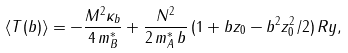Convert formula to latex. <formula><loc_0><loc_0><loc_500><loc_500>\langle T ( b ) \rangle = - \frac { M ^ { 2 } \kappa _ { b } } { 4 \, m _ { B } ^ { * } } + \frac { N ^ { 2 } } { 2 \, m _ { A } ^ { * } \, b } \, ( 1 + b z _ { 0 } - b ^ { 2 } z _ { 0 } ^ { 2 } / 2 ) \, R y ,</formula> 